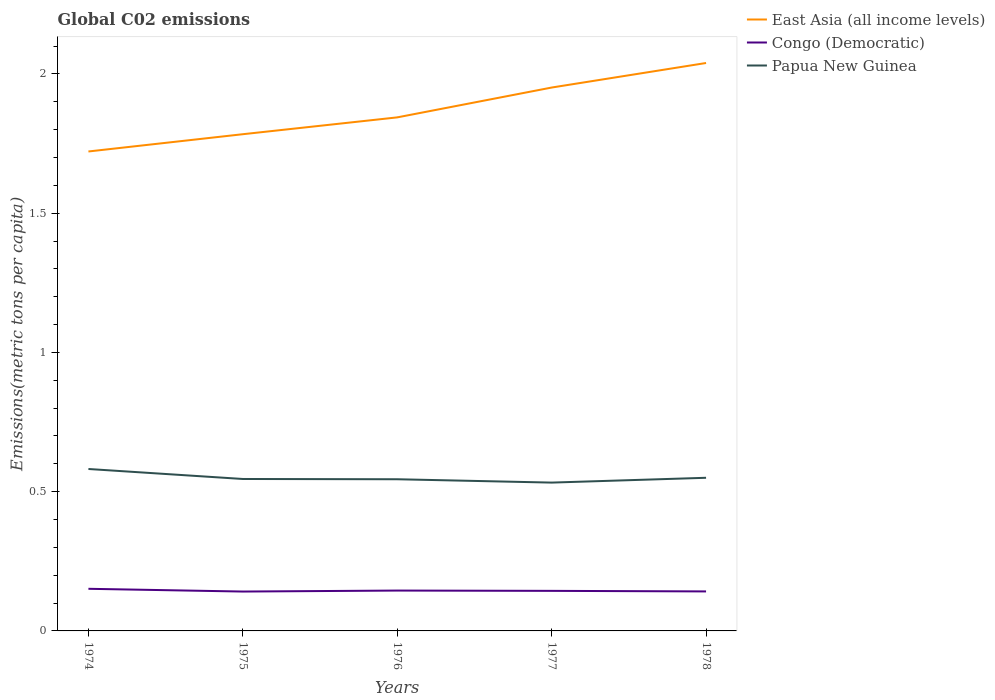How many different coloured lines are there?
Keep it short and to the point. 3. Across all years, what is the maximum amount of CO2 emitted in in East Asia (all income levels)?
Keep it short and to the point. 1.72. In which year was the amount of CO2 emitted in in Congo (Democratic) maximum?
Offer a very short reply. 1975. What is the total amount of CO2 emitted in in East Asia (all income levels) in the graph?
Offer a terse response. -0.11. What is the difference between the highest and the second highest amount of CO2 emitted in in Papua New Guinea?
Your answer should be very brief. 0.05. How many lines are there?
Your answer should be compact. 3. What is the difference between two consecutive major ticks on the Y-axis?
Your answer should be compact. 0.5. Are the values on the major ticks of Y-axis written in scientific E-notation?
Your response must be concise. No. How many legend labels are there?
Make the answer very short. 3. What is the title of the graph?
Offer a very short reply. Global C02 emissions. What is the label or title of the Y-axis?
Provide a succinct answer. Emissions(metric tons per capita). What is the Emissions(metric tons per capita) of East Asia (all income levels) in 1974?
Your answer should be very brief. 1.72. What is the Emissions(metric tons per capita) in Congo (Democratic) in 1974?
Your answer should be compact. 0.15. What is the Emissions(metric tons per capita) of Papua New Guinea in 1974?
Give a very brief answer. 0.58. What is the Emissions(metric tons per capita) in East Asia (all income levels) in 1975?
Give a very brief answer. 1.78. What is the Emissions(metric tons per capita) of Congo (Democratic) in 1975?
Keep it short and to the point. 0.14. What is the Emissions(metric tons per capita) in Papua New Guinea in 1975?
Provide a succinct answer. 0.55. What is the Emissions(metric tons per capita) in East Asia (all income levels) in 1976?
Give a very brief answer. 1.84. What is the Emissions(metric tons per capita) in Congo (Democratic) in 1976?
Your answer should be very brief. 0.14. What is the Emissions(metric tons per capita) of Papua New Guinea in 1976?
Offer a terse response. 0.54. What is the Emissions(metric tons per capita) of East Asia (all income levels) in 1977?
Ensure brevity in your answer.  1.95. What is the Emissions(metric tons per capita) in Congo (Democratic) in 1977?
Provide a succinct answer. 0.14. What is the Emissions(metric tons per capita) in Papua New Guinea in 1977?
Your response must be concise. 0.53. What is the Emissions(metric tons per capita) in East Asia (all income levels) in 1978?
Keep it short and to the point. 2.04. What is the Emissions(metric tons per capita) of Congo (Democratic) in 1978?
Make the answer very short. 0.14. What is the Emissions(metric tons per capita) in Papua New Guinea in 1978?
Offer a very short reply. 0.55. Across all years, what is the maximum Emissions(metric tons per capita) in East Asia (all income levels)?
Make the answer very short. 2.04. Across all years, what is the maximum Emissions(metric tons per capita) in Congo (Democratic)?
Offer a terse response. 0.15. Across all years, what is the maximum Emissions(metric tons per capita) in Papua New Guinea?
Provide a short and direct response. 0.58. Across all years, what is the minimum Emissions(metric tons per capita) in East Asia (all income levels)?
Your answer should be compact. 1.72. Across all years, what is the minimum Emissions(metric tons per capita) in Congo (Democratic)?
Offer a very short reply. 0.14. Across all years, what is the minimum Emissions(metric tons per capita) in Papua New Guinea?
Your answer should be very brief. 0.53. What is the total Emissions(metric tons per capita) of East Asia (all income levels) in the graph?
Keep it short and to the point. 9.34. What is the total Emissions(metric tons per capita) in Congo (Democratic) in the graph?
Ensure brevity in your answer.  0.72. What is the total Emissions(metric tons per capita) in Papua New Guinea in the graph?
Provide a short and direct response. 2.75. What is the difference between the Emissions(metric tons per capita) in East Asia (all income levels) in 1974 and that in 1975?
Your answer should be compact. -0.06. What is the difference between the Emissions(metric tons per capita) in Congo (Democratic) in 1974 and that in 1975?
Provide a succinct answer. 0.01. What is the difference between the Emissions(metric tons per capita) in Papua New Guinea in 1974 and that in 1975?
Offer a very short reply. 0.04. What is the difference between the Emissions(metric tons per capita) in East Asia (all income levels) in 1974 and that in 1976?
Give a very brief answer. -0.12. What is the difference between the Emissions(metric tons per capita) of Congo (Democratic) in 1974 and that in 1976?
Offer a very short reply. 0.01. What is the difference between the Emissions(metric tons per capita) of Papua New Guinea in 1974 and that in 1976?
Your answer should be very brief. 0.04. What is the difference between the Emissions(metric tons per capita) in East Asia (all income levels) in 1974 and that in 1977?
Ensure brevity in your answer.  -0.23. What is the difference between the Emissions(metric tons per capita) of Congo (Democratic) in 1974 and that in 1977?
Make the answer very short. 0.01. What is the difference between the Emissions(metric tons per capita) of Papua New Guinea in 1974 and that in 1977?
Your answer should be compact. 0.05. What is the difference between the Emissions(metric tons per capita) in East Asia (all income levels) in 1974 and that in 1978?
Offer a terse response. -0.32. What is the difference between the Emissions(metric tons per capita) of Congo (Democratic) in 1974 and that in 1978?
Your response must be concise. 0.01. What is the difference between the Emissions(metric tons per capita) of Papua New Guinea in 1974 and that in 1978?
Keep it short and to the point. 0.03. What is the difference between the Emissions(metric tons per capita) in East Asia (all income levels) in 1975 and that in 1976?
Offer a terse response. -0.06. What is the difference between the Emissions(metric tons per capita) in Congo (Democratic) in 1975 and that in 1976?
Ensure brevity in your answer.  -0. What is the difference between the Emissions(metric tons per capita) in Papua New Guinea in 1975 and that in 1976?
Give a very brief answer. 0. What is the difference between the Emissions(metric tons per capita) of East Asia (all income levels) in 1975 and that in 1977?
Provide a short and direct response. -0.17. What is the difference between the Emissions(metric tons per capita) in Congo (Democratic) in 1975 and that in 1977?
Give a very brief answer. -0. What is the difference between the Emissions(metric tons per capita) of Papua New Guinea in 1975 and that in 1977?
Give a very brief answer. 0.01. What is the difference between the Emissions(metric tons per capita) in East Asia (all income levels) in 1975 and that in 1978?
Offer a terse response. -0.26. What is the difference between the Emissions(metric tons per capita) of Congo (Democratic) in 1975 and that in 1978?
Offer a terse response. -0. What is the difference between the Emissions(metric tons per capita) in Papua New Guinea in 1975 and that in 1978?
Offer a very short reply. -0. What is the difference between the Emissions(metric tons per capita) in East Asia (all income levels) in 1976 and that in 1977?
Keep it short and to the point. -0.11. What is the difference between the Emissions(metric tons per capita) in Congo (Democratic) in 1976 and that in 1977?
Provide a succinct answer. 0. What is the difference between the Emissions(metric tons per capita) in Papua New Guinea in 1976 and that in 1977?
Provide a succinct answer. 0.01. What is the difference between the Emissions(metric tons per capita) in East Asia (all income levels) in 1976 and that in 1978?
Keep it short and to the point. -0.2. What is the difference between the Emissions(metric tons per capita) in Congo (Democratic) in 1976 and that in 1978?
Your response must be concise. 0. What is the difference between the Emissions(metric tons per capita) of Papua New Guinea in 1976 and that in 1978?
Give a very brief answer. -0.01. What is the difference between the Emissions(metric tons per capita) in East Asia (all income levels) in 1977 and that in 1978?
Keep it short and to the point. -0.09. What is the difference between the Emissions(metric tons per capita) in Congo (Democratic) in 1977 and that in 1978?
Your response must be concise. 0. What is the difference between the Emissions(metric tons per capita) of Papua New Guinea in 1977 and that in 1978?
Ensure brevity in your answer.  -0.02. What is the difference between the Emissions(metric tons per capita) of East Asia (all income levels) in 1974 and the Emissions(metric tons per capita) of Congo (Democratic) in 1975?
Offer a terse response. 1.58. What is the difference between the Emissions(metric tons per capita) in East Asia (all income levels) in 1974 and the Emissions(metric tons per capita) in Papua New Guinea in 1975?
Your response must be concise. 1.18. What is the difference between the Emissions(metric tons per capita) in Congo (Democratic) in 1974 and the Emissions(metric tons per capita) in Papua New Guinea in 1975?
Your response must be concise. -0.39. What is the difference between the Emissions(metric tons per capita) of East Asia (all income levels) in 1974 and the Emissions(metric tons per capita) of Congo (Democratic) in 1976?
Offer a terse response. 1.58. What is the difference between the Emissions(metric tons per capita) of East Asia (all income levels) in 1974 and the Emissions(metric tons per capita) of Papua New Guinea in 1976?
Your response must be concise. 1.18. What is the difference between the Emissions(metric tons per capita) of Congo (Democratic) in 1974 and the Emissions(metric tons per capita) of Papua New Guinea in 1976?
Provide a succinct answer. -0.39. What is the difference between the Emissions(metric tons per capita) of East Asia (all income levels) in 1974 and the Emissions(metric tons per capita) of Congo (Democratic) in 1977?
Your response must be concise. 1.58. What is the difference between the Emissions(metric tons per capita) of East Asia (all income levels) in 1974 and the Emissions(metric tons per capita) of Papua New Guinea in 1977?
Keep it short and to the point. 1.19. What is the difference between the Emissions(metric tons per capita) of Congo (Democratic) in 1974 and the Emissions(metric tons per capita) of Papua New Guinea in 1977?
Offer a terse response. -0.38. What is the difference between the Emissions(metric tons per capita) of East Asia (all income levels) in 1974 and the Emissions(metric tons per capita) of Congo (Democratic) in 1978?
Offer a terse response. 1.58. What is the difference between the Emissions(metric tons per capita) of East Asia (all income levels) in 1974 and the Emissions(metric tons per capita) of Papua New Guinea in 1978?
Offer a terse response. 1.17. What is the difference between the Emissions(metric tons per capita) of Congo (Democratic) in 1974 and the Emissions(metric tons per capita) of Papua New Guinea in 1978?
Provide a succinct answer. -0.4. What is the difference between the Emissions(metric tons per capita) of East Asia (all income levels) in 1975 and the Emissions(metric tons per capita) of Congo (Democratic) in 1976?
Offer a very short reply. 1.64. What is the difference between the Emissions(metric tons per capita) of East Asia (all income levels) in 1975 and the Emissions(metric tons per capita) of Papua New Guinea in 1976?
Keep it short and to the point. 1.24. What is the difference between the Emissions(metric tons per capita) of Congo (Democratic) in 1975 and the Emissions(metric tons per capita) of Papua New Guinea in 1976?
Your response must be concise. -0.4. What is the difference between the Emissions(metric tons per capita) in East Asia (all income levels) in 1975 and the Emissions(metric tons per capita) in Congo (Democratic) in 1977?
Your answer should be compact. 1.64. What is the difference between the Emissions(metric tons per capita) of East Asia (all income levels) in 1975 and the Emissions(metric tons per capita) of Papua New Guinea in 1977?
Offer a terse response. 1.25. What is the difference between the Emissions(metric tons per capita) of Congo (Democratic) in 1975 and the Emissions(metric tons per capita) of Papua New Guinea in 1977?
Offer a terse response. -0.39. What is the difference between the Emissions(metric tons per capita) of East Asia (all income levels) in 1975 and the Emissions(metric tons per capita) of Congo (Democratic) in 1978?
Your response must be concise. 1.64. What is the difference between the Emissions(metric tons per capita) in East Asia (all income levels) in 1975 and the Emissions(metric tons per capita) in Papua New Guinea in 1978?
Provide a short and direct response. 1.23. What is the difference between the Emissions(metric tons per capita) of Congo (Democratic) in 1975 and the Emissions(metric tons per capita) of Papua New Guinea in 1978?
Offer a very short reply. -0.41. What is the difference between the Emissions(metric tons per capita) of East Asia (all income levels) in 1976 and the Emissions(metric tons per capita) of Congo (Democratic) in 1977?
Keep it short and to the point. 1.7. What is the difference between the Emissions(metric tons per capita) of East Asia (all income levels) in 1976 and the Emissions(metric tons per capita) of Papua New Guinea in 1977?
Provide a succinct answer. 1.31. What is the difference between the Emissions(metric tons per capita) in Congo (Democratic) in 1976 and the Emissions(metric tons per capita) in Papua New Guinea in 1977?
Give a very brief answer. -0.39. What is the difference between the Emissions(metric tons per capita) in East Asia (all income levels) in 1976 and the Emissions(metric tons per capita) in Congo (Democratic) in 1978?
Give a very brief answer. 1.7. What is the difference between the Emissions(metric tons per capita) of East Asia (all income levels) in 1976 and the Emissions(metric tons per capita) of Papua New Guinea in 1978?
Provide a succinct answer. 1.29. What is the difference between the Emissions(metric tons per capita) in Congo (Democratic) in 1976 and the Emissions(metric tons per capita) in Papua New Guinea in 1978?
Offer a terse response. -0.4. What is the difference between the Emissions(metric tons per capita) in East Asia (all income levels) in 1977 and the Emissions(metric tons per capita) in Congo (Democratic) in 1978?
Offer a terse response. 1.81. What is the difference between the Emissions(metric tons per capita) of East Asia (all income levels) in 1977 and the Emissions(metric tons per capita) of Papua New Guinea in 1978?
Offer a very short reply. 1.4. What is the difference between the Emissions(metric tons per capita) of Congo (Democratic) in 1977 and the Emissions(metric tons per capita) of Papua New Guinea in 1978?
Provide a succinct answer. -0.41. What is the average Emissions(metric tons per capita) in East Asia (all income levels) per year?
Make the answer very short. 1.87. What is the average Emissions(metric tons per capita) of Congo (Democratic) per year?
Your answer should be very brief. 0.14. What is the average Emissions(metric tons per capita) in Papua New Guinea per year?
Give a very brief answer. 0.55. In the year 1974, what is the difference between the Emissions(metric tons per capita) of East Asia (all income levels) and Emissions(metric tons per capita) of Congo (Democratic)?
Offer a terse response. 1.57. In the year 1974, what is the difference between the Emissions(metric tons per capita) of East Asia (all income levels) and Emissions(metric tons per capita) of Papua New Guinea?
Your answer should be compact. 1.14. In the year 1974, what is the difference between the Emissions(metric tons per capita) in Congo (Democratic) and Emissions(metric tons per capita) in Papua New Guinea?
Give a very brief answer. -0.43. In the year 1975, what is the difference between the Emissions(metric tons per capita) in East Asia (all income levels) and Emissions(metric tons per capita) in Congo (Democratic)?
Provide a short and direct response. 1.64. In the year 1975, what is the difference between the Emissions(metric tons per capita) of East Asia (all income levels) and Emissions(metric tons per capita) of Papua New Guinea?
Your answer should be compact. 1.24. In the year 1975, what is the difference between the Emissions(metric tons per capita) in Congo (Democratic) and Emissions(metric tons per capita) in Papua New Guinea?
Ensure brevity in your answer.  -0.4. In the year 1976, what is the difference between the Emissions(metric tons per capita) in East Asia (all income levels) and Emissions(metric tons per capita) in Congo (Democratic)?
Ensure brevity in your answer.  1.7. In the year 1976, what is the difference between the Emissions(metric tons per capita) in East Asia (all income levels) and Emissions(metric tons per capita) in Papua New Guinea?
Provide a short and direct response. 1.3. In the year 1976, what is the difference between the Emissions(metric tons per capita) in Congo (Democratic) and Emissions(metric tons per capita) in Papua New Guinea?
Keep it short and to the point. -0.4. In the year 1977, what is the difference between the Emissions(metric tons per capita) in East Asia (all income levels) and Emissions(metric tons per capita) in Congo (Democratic)?
Ensure brevity in your answer.  1.81. In the year 1977, what is the difference between the Emissions(metric tons per capita) in East Asia (all income levels) and Emissions(metric tons per capita) in Papua New Guinea?
Your response must be concise. 1.42. In the year 1977, what is the difference between the Emissions(metric tons per capita) of Congo (Democratic) and Emissions(metric tons per capita) of Papua New Guinea?
Your answer should be compact. -0.39. In the year 1978, what is the difference between the Emissions(metric tons per capita) of East Asia (all income levels) and Emissions(metric tons per capita) of Congo (Democratic)?
Offer a very short reply. 1.9. In the year 1978, what is the difference between the Emissions(metric tons per capita) of East Asia (all income levels) and Emissions(metric tons per capita) of Papua New Guinea?
Your response must be concise. 1.49. In the year 1978, what is the difference between the Emissions(metric tons per capita) in Congo (Democratic) and Emissions(metric tons per capita) in Papua New Guinea?
Your response must be concise. -0.41. What is the ratio of the Emissions(metric tons per capita) in East Asia (all income levels) in 1974 to that in 1975?
Provide a short and direct response. 0.97. What is the ratio of the Emissions(metric tons per capita) of Congo (Democratic) in 1974 to that in 1975?
Your answer should be very brief. 1.07. What is the ratio of the Emissions(metric tons per capita) of Papua New Guinea in 1974 to that in 1975?
Your answer should be compact. 1.07. What is the ratio of the Emissions(metric tons per capita) in East Asia (all income levels) in 1974 to that in 1976?
Your response must be concise. 0.93. What is the ratio of the Emissions(metric tons per capita) in Congo (Democratic) in 1974 to that in 1976?
Offer a terse response. 1.04. What is the ratio of the Emissions(metric tons per capita) in Papua New Guinea in 1974 to that in 1976?
Ensure brevity in your answer.  1.07. What is the ratio of the Emissions(metric tons per capita) in East Asia (all income levels) in 1974 to that in 1977?
Make the answer very short. 0.88. What is the ratio of the Emissions(metric tons per capita) in Congo (Democratic) in 1974 to that in 1977?
Give a very brief answer. 1.05. What is the ratio of the Emissions(metric tons per capita) in Papua New Guinea in 1974 to that in 1977?
Provide a succinct answer. 1.09. What is the ratio of the Emissions(metric tons per capita) in East Asia (all income levels) in 1974 to that in 1978?
Ensure brevity in your answer.  0.84. What is the ratio of the Emissions(metric tons per capita) of Congo (Democratic) in 1974 to that in 1978?
Provide a succinct answer. 1.07. What is the ratio of the Emissions(metric tons per capita) of Papua New Guinea in 1974 to that in 1978?
Your answer should be compact. 1.06. What is the ratio of the Emissions(metric tons per capita) of East Asia (all income levels) in 1975 to that in 1976?
Make the answer very short. 0.97. What is the ratio of the Emissions(metric tons per capita) of Congo (Democratic) in 1975 to that in 1976?
Your answer should be compact. 0.98. What is the ratio of the Emissions(metric tons per capita) in East Asia (all income levels) in 1975 to that in 1977?
Your answer should be compact. 0.91. What is the ratio of the Emissions(metric tons per capita) in Congo (Democratic) in 1975 to that in 1977?
Give a very brief answer. 0.98. What is the ratio of the Emissions(metric tons per capita) of Papua New Guinea in 1975 to that in 1977?
Your answer should be very brief. 1.02. What is the ratio of the Emissions(metric tons per capita) in East Asia (all income levels) in 1975 to that in 1978?
Make the answer very short. 0.87. What is the ratio of the Emissions(metric tons per capita) of Papua New Guinea in 1975 to that in 1978?
Offer a very short reply. 0.99. What is the ratio of the Emissions(metric tons per capita) of East Asia (all income levels) in 1976 to that in 1977?
Keep it short and to the point. 0.95. What is the ratio of the Emissions(metric tons per capita) in Congo (Democratic) in 1976 to that in 1977?
Make the answer very short. 1.01. What is the ratio of the Emissions(metric tons per capita) of Papua New Guinea in 1976 to that in 1977?
Offer a very short reply. 1.02. What is the ratio of the Emissions(metric tons per capita) of East Asia (all income levels) in 1976 to that in 1978?
Make the answer very short. 0.9. What is the ratio of the Emissions(metric tons per capita) in Congo (Democratic) in 1976 to that in 1978?
Your answer should be compact. 1.02. What is the ratio of the Emissions(metric tons per capita) in East Asia (all income levels) in 1977 to that in 1978?
Provide a succinct answer. 0.96. What is the ratio of the Emissions(metric tons per capita) in Congo (Democratic) in 1977 to that in 1978?
Provide a succinct answer. 1.01. What is the ratio of the Emissions(metric tons per capita) of Papua New Guinea in 1977 to that in 1978?
Offer a very short reply. 0.97. What is the difference between the highest and the second highest Emissions(metric tons per capita) in East Asia (all income levels)?
Make the answer very short. 0.09. What is the difference between the highest and the second highest Emissions(metric tons per capita) of Congo (Democratic)?
Offer a very short reply. 0.01. What is the difference between the highest and the second highest Emissions(metric tons per capita) in Papua New Guinea?
Your answer should be compact. 0.03. What is the difference between the highest and the lowest Emissions(metric tons per capita) of East Asia (all income levels)?
Provide a succinct answer. 0.32. What is the difference between the highest and the lowest Emissions(metric tons per capita) in Congo (Democratic)?
Offer a very short reply. 0.01. What is the difference between the highest and the lowest Emissions(metric tons per capita) of Papua New Guinea?
Offer a very short reply. 0.05. 